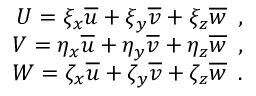<formula> <loc_0><loc_0><loc_500><loc_500>\begin{array} { r } { { U = \xi _ { x } \overline { u } + \xi _ { y } \overline { v } + \xi _ { z } \overline { w } \, , } } \\ { { V = \eta _ { x } \overline { u } + \eta _ { y } \overline { v } + \eta _ { z } \overline { w } \, , } } \\ { { W = \zeta _ { x } \overline { u } + \zeta _ { y } \overline { v } + \zeta _ { z } \overline { w } \, . } } \end{array}</formula> 